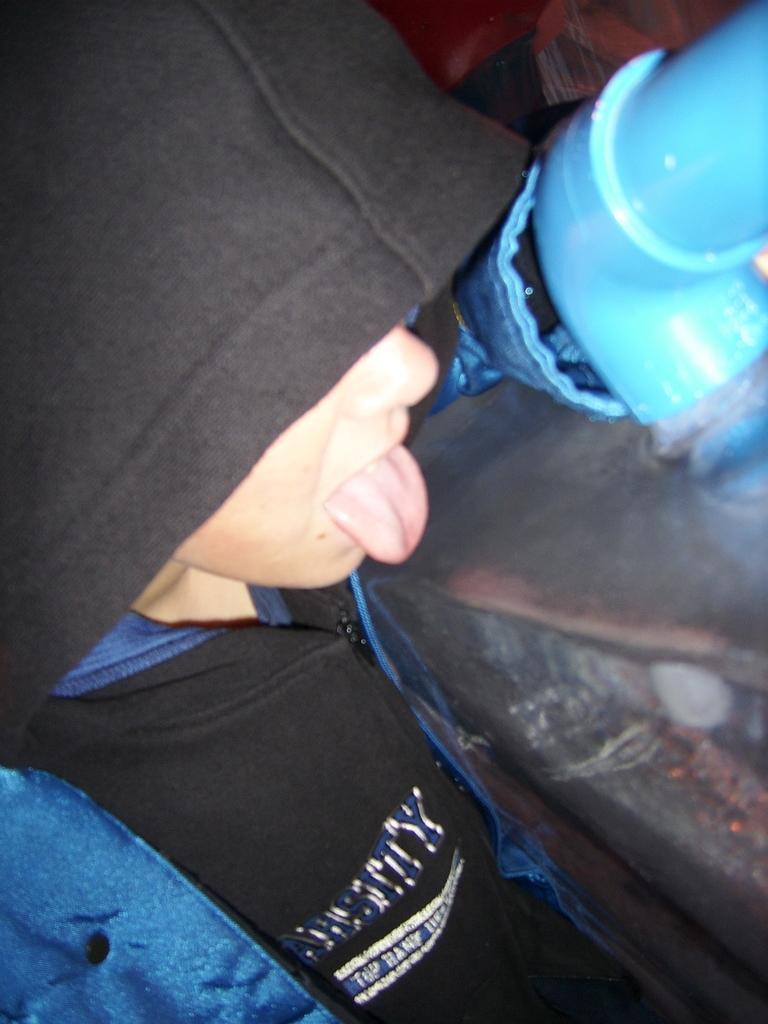Could you give a brief overview of what you see in this image? In the picture we can see a person standing and wearing a hoodie with a cap which is black in color and some part in blue beside the person we can see a pipe which is also blue in color. 